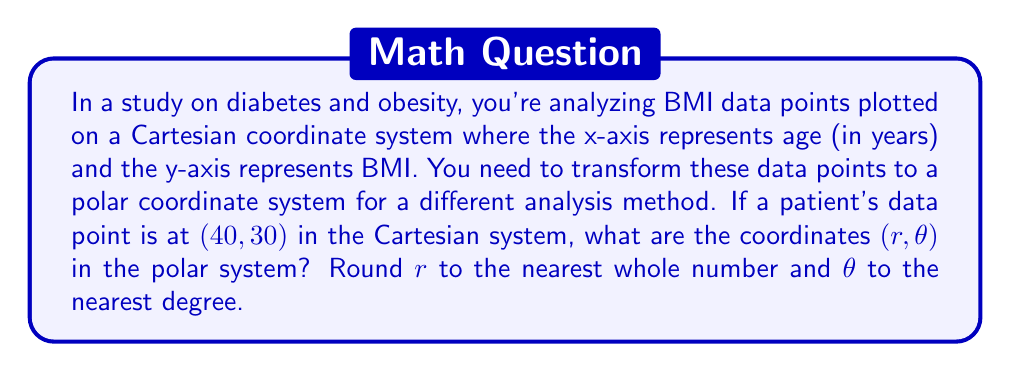Help me with this question. To transform a point from Cartesian coordinates $(x, y)$ to polar coordinates $(r, \theta)$, we use the following formulas:

1) $r = \sqrt{x^2 + y^2}$
2) $\theta = \tan^{-1}(\frac{y}{x})$

For the given point (40, 30):

1) Calculating $r$:
   $$r = \sqrt{40^2 + 30^2} = \sqrt{1600 + 900} = \sqrt{2500} = 50$$

2) Calculating $\theta$:
   $$\theta = \tan^{-1}(\frac{30}{40}) = \tan^{-1}(0.75)$$

   Using a calculator or trigonometric tables, we find:
   $$\theta \approx 36.87^\circ$$

Rounding $r$ to the nearest whole number: 50
Rounding $\theta$ to the nearest degree: 37°

Therefore, the polar coordinates are approximately (50, 37°).

[asy]
import geometry;

size(200);
real r = 50;
real theta = 36.87 * pi / 180;

draw((-10,0)--(60,0), arrow=Arrow(TeXHead));
draw((0,-10)--(0,40), arrow=Arrow(TeXHead));

dot((40,30), red);
draw((0,0)--(40,30), blue);

label("(40, 30)", (42,32), NE);
label("$r = 50$", (20,15), NW);
label("$\theta = 37°$", (10,5), N);

draw(arc((0,0), 10, 0, theta), arrow=Arrow(TeXHead));
[/asy]
Answer: (50, 37°) 